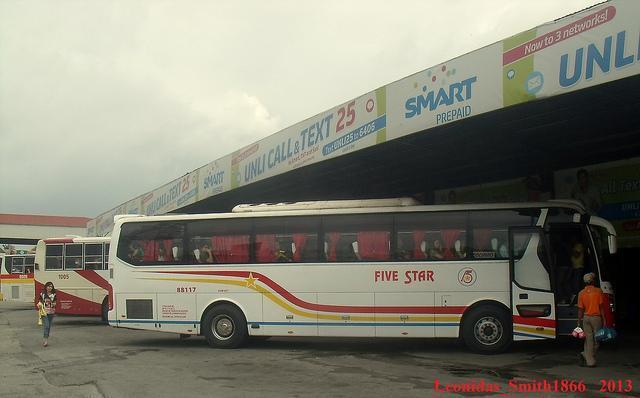How many buses are there?
Give a very brief answer. 3. How many vehicles?
Give a very brief answer. 3. 